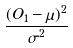Convert formula to latex. <formula><loc_0><loc_0><loc_500><loc_500>\frac { ( O _ { 1 } - \mu ) ^ { 2 } } { \sigma ^ { 2 } }</formula> 